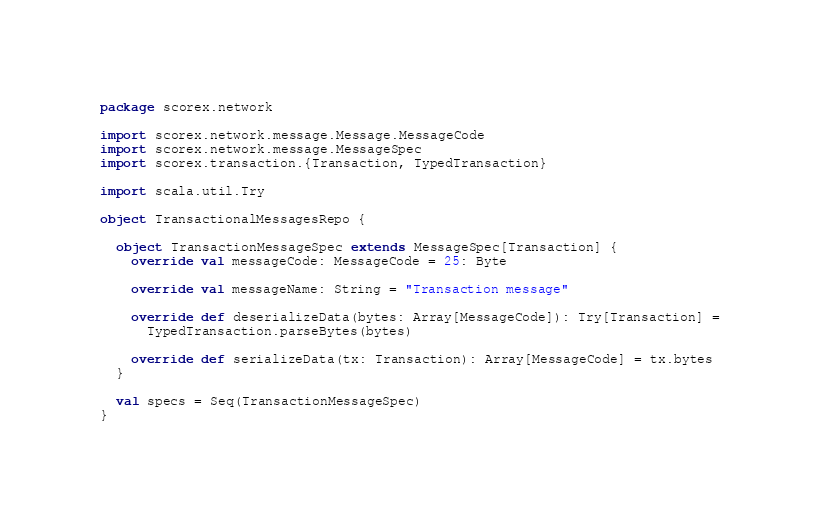<code> <loc_0><loc_0><loc_500><loc_500><_Scala_>package scorex.network

import scorex.network.message.Message.MessageCode
import scorex.network.message.MessageSpec
import scorex.transaction.{Transaction, TypedTransaction}

import scala.util.Try

object TransactionalMessagesRepo {

  object TransactionMessageSpec extends MessageSpec[Transaction] {
    override val messageCode: MessageCode = 25: Byte

    override val messageName: String = "Transaction message"

    override def deserializeData(bytes: Array[MessageCode]): Try[Transaction] =
      TypedTransaction.parseBytes(bytes)

    override def serializeData(tx: Transaction): Array[MessageCode] = tx.bytes
  }

  val specs = Seq(TransactionMessageSpec)
}
</code> 